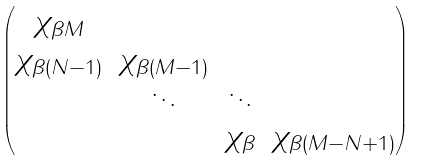Convert formula to latex. <formula><loc_0><loc_0><loc_500><loc_500>\begin{pmatrix} \chi _ { \beta M } \\ \chi _ { \beta ( N - 1 ) } & \chi _ { \beta ( M - 1 ) } \\ & \ddots & \ddots \\ & & \chi _ { \beta } & \chi _ { \beta ( M - N + 1 ) } \end{pmatrix}</formula> 